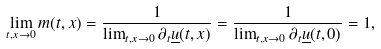<formula> <loc_0><loc_0><loc_500><loc_500>\lim _ { t , x \rightarrow 0 } m ( t , x ) = \frac { 1 } { \lim _ { t , x \rightarrow 0 } \partial _ { t } \underline { u } ( t , x ) } = \frac { 1 } { \lim _ { t , x \rightarrow 0 } \partial _ { t } \underline { u } ( t , 0 ) } = 1 , \\</formula> 